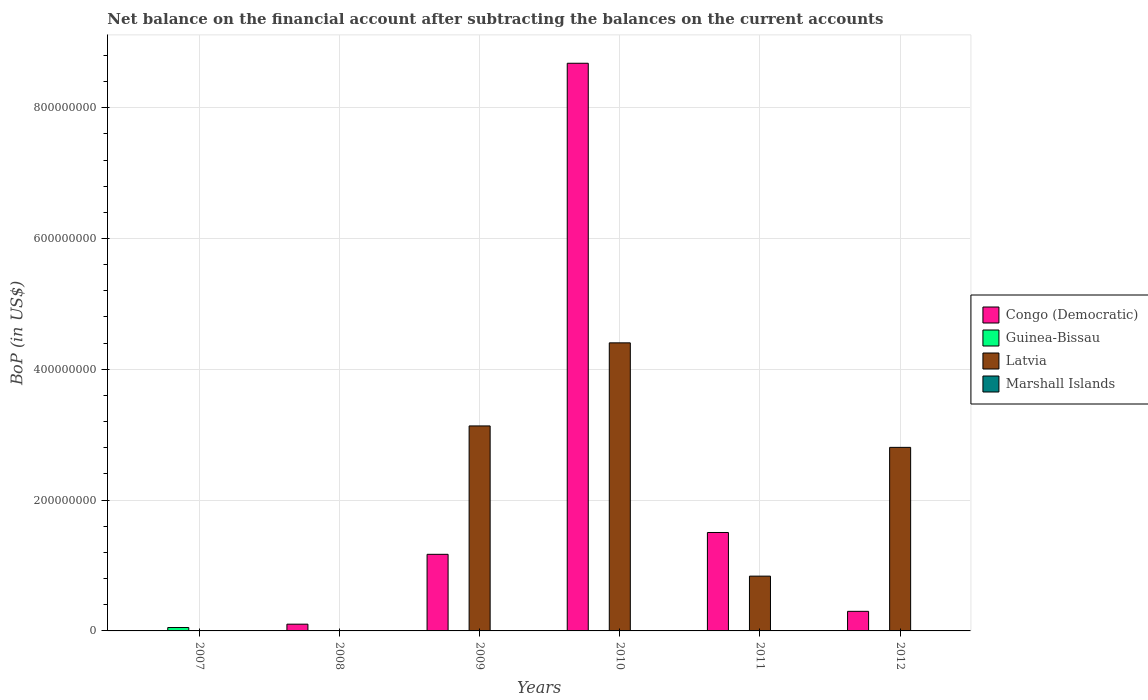Are the number of bars per tick equal to the number of legend labels?
Offer a very short reply. No. How many bars are there on the 2nd tick from the right?
Your response must be concise. 2. What is the label of the 2nd group of bars from the left?
Your answer should be compact. 2008. What is the Balance of Payments in Guinea-Bissau in 2008?
Give a very brief answer. 0. Across all years, what is the maximum Balance of Payments in Congo (Democratic)?
Ensure brevity in your answer.  8.68e+08. In which year was the Balance of Payments in Latvia maximum?
Your answer should be very brief. 2010. What is the total Balance of Payments in Guinea-Bissau in the graph?
Give a very brief answer. 5.20e+06. What is the difference between the Balance of Payments in Congo (Democratic) in 2010 and that in 2012?
Offer a terse response. 8.38e+08. What is the average Balance of Payments in Marshall Islands per year?
Provide a short and direct response. 0. What is the ratio of the Balance of Payments in Congo (Democratic) in 2010 to that in 2012?
Ensure brevity in your answer.  28.99. What is the difference between the highest and the second highest Balance of Payments in Latvia?
Offer a terse response. 1.27e+08. What is the difference between the highest and the lowest Balance of Payments in Congo (Democratic)?
Your answer should be very brief. 8.68e+08. In how many years, is the Balance of Payments in Congo (Democratic) greater than the average Balance of Payments in Congo (Democratic) taken over all years?
Your response must be concise. 1. Is it the case that in every year, the sum of the Balance of Payments in Latvia and Balance of Payments in Marshall Islands is greater than the sum of Balance of Payments in Congo (Democratic) and Balance of Payments in Guinea-Bissau?
Offer a very short reply. No. Is it the case that in every year, the sum of the Balance of Payments in Guinea-Bissau and Balance of Payments in Congo (Democratic) is greater than the Balance of Payments in Marshall Islands?
Your response must be concise. Yes. How many bars are there?
Ensure brevity in your answer.  10. Are all the bars in the graph horizontal?
Give a very brief answer. No. What is the difference between two consecutive major ticks on the Y-axis?
Keep it short and to the point. 2.00e+08. Are the values on the major ticks of Y-axis written in scientific E-notation?
Your answer should be very brief. No. Does the graph contain grids?
Offer a terse response. Yes. How many legend labels are there?
Give a very brief answer. 4. What is the title of the graph?
Provide a succinct answer. Net balance on the financial account after subtracting the balances on the current accounts. What is the label or title of the X-axis?
Give a very brief answer. Years. What is the label or title of the Y-axis?
Offer a terse response. BoP (in US$). What is the BoP (in US$) in Guinea-Bissau in 2007?
Offer a very short reply. 5.20e+06. What is the BoP (in US$) in Latvia in 2007?
Provide a short and direct response. 0. What is the BoP (in US$) in Congo (Democratic) in 2008?
Give a very brief answer. 1.03e+07. What is the BoP (in US$) of Guinea-Bissau in 2008?
Provide a succinct answer. 0. What is the BoP (in US$) of Marshall Islands in 2008?
Provide a succinct answer. 0. What is the BoP (in US$) of Congo (Democratic) in 2009?
Offer a very short reply. 1.17e+08. What is the BoP (in US$) of Guinea-Bissau in 2009?
Provide a succinct answer. 0. What is the BoP (in US$) in Latvia in 2009?
Provide a short and direct response. 3.13e+08. What is the BoP (in US$) of Congo (Democratic) in 2010?
Offer a very short reply. 8.68e+08. What is the BoP (in US$) in Guinea-Bissau in 2010?
Your answer should be compact. 0. What is the BoP (in US$) of Latvia in 2010?
Keep it short and to the point. 4.40e+08. What is the BoP (in US$) in Marshall Islands in 2010?
Keep it short and to the point. 0. What is the BoP (in US$) in Congo (Democratic) in 2011?
Offer a terse response. 1.50e+08. What is the BoP (in US$) in Guinea-Bissau in 2011?
Your answer should be very brief. 0. What is the BoP (in US$) of Latvia in 2011?
Your response must be concise. 8.38e+07. What is the BoP (in US$) in Marshall Islands in 2011?
Make the answer very short. 0. What is the BoP (in US$) in Congo (Democratic) in 2012?
Your response must be concise. 2.99e+07. What is the BoP (in US$) of Guinea-Bissau in 2012?
Your response must be concise. 0. What is the BoP (in US$) in Latvia in 2012?
Keep it short and to the point. 2.81e+08. What is the BoP (in US$) of Marshall Islands in 2012?
Ensure brevity in your answer.  0. Across all years, what is the maximum BoP (in US$) of Congo (Democratic)?
Give a very brief answer. 8.68e+08. Across all years, what is the maximum BoP (in US$) in Guinea-Bissau?
Provide a succinct answer. 5.20e+06. Across all years, what is the maximum BoP (in US$) in Latvia?
Ensure brevity in your answer.  4.40e+08. Across all years, what is the minimum BoP (in US$) of Latvia?
Keep it short and to the point. 0. What is the total BoP (in US$) in Congo (Democratic) in the graph?
Offer a very short reply. 1.18e+09. What is the total BoP (in US$) in Guinea-Bissau in the graph?
Offer a very short reply. 5.20e+06. What is the total BoP (in US$) of Latvia in the graph?
Your answer should be compact. 1.12e+09. What is the difference between the BoP (in US$) of Congo (Democratic) in 2008 and that in 2009?
Give a very brief answer. -1.07e+08. What is the difference between the BoP (in US$) of Congo (Democratic) in 2008 and that in 2010?
Offer a very short reply. -8.58e+08. What is the difference between the BoP (in US$) in Congo (Democratic) in 2008 and that in 2011?
Provide a succinct answer. -1.40e+08. What is the difference between the BoP (in US$) of Congo (Democratic) in 2008 and that in 2012?
Your answer should be very brief. -1.96e+07. What is the difference between the BoP (in US$) in Congo (Democratic) in 2009 and that in 2010?
Keep it short and to the point. -7.51e+08. What is the difference between the BoP (in US$) of Latvia in 2009 and that in 2010?
Ensure brevity in your answer.  -1.27e+08. What is the difference between the BoP (in US$) in Congo (Democratic) in 2009 and that in 2011?
Give a very brief answer. -3.34e+07. What is the difference between the BoP (in US$) of Latvia in 2009 and that in 2011?
Give a very brief answer. 2.30e+08. What is the difference between the BoP (in US$) of Congo (Democratic) in 2009 and that in 2012?
Give a very brief answer. 8.72e+07. What is the difference between the BoP (in US$) of Latvia in 2009 and that in 2012?
Give a very brief answer. 3.28e+07. What is the difference between the BoP (in US$) in Congo (Democratic) in 2010 and that in 2011?
Provide a succinct answer. 7.17e+08. What is the difference between the BoP (in US$) in Latvia in 2010 and that in 2011?
Give a very brief answer. 3.57e+08. What is the difference between the BoP (in US$) in Congo (Democratic) in 2010 and that in 2012?
Keep it short and to the point. 8.38e+08. What is the difference between the BoP (in US$) in Latvia in 2010 and that in 2012?
Provide a succinct answer. 1.60e+08. What is the difference between the BoP (in US$) of Congo (Democratic) in 2011 and that in 2012?
Offer a terse response. 1.21e+08. What is the difference between the BoP (in US$) of Latvia in 2011 and that in 2012?
Provide a short and direct response. -1.97e+08. What is the difference between the BoP (in US$) of Guinea-Bissau in 2007 and the BoP (in US$) of Latvia in 2009?
Offer a very short reply. -3.08e+08. What is the difference between the BoP (in US$) of Guinea-Bissau in 2007 and the BoP (in US$) of Latvia in 2010?
Keep it short and to the point. -4.35e+08. What is the difference between the BoP (in US$) in Guinea-Bissau in 2007 and the BoP (in US$) in Latvia in 2011?
Ensure brevity in your answer.  -7.86e+07. What is the difference between the BoP (in US$) in Guinea-Bissau in 2007 and the BoP (in US$) in Latvia in 2012?
Provide a succinct answer. -2.75e+08. What is the difference between the BoP (in US$) in Congo (Democratic) in 2008 and the BoP (in US$) in Latvia in 2009?
Your answer should be very brief. -3.03e+08. What is the difference between the BoP (in US$) of Congo (Democratic) in 2008 and the BoP (in US$) of Latvia in 2010?
Ensure brevity in your answer.  -4.30e+08. What is the difference between the BoP (in US$) in Congo (Democratic) in 2008 and the BoP (in US$) in Latvia in 2011?
Ensure brevity in your answer.  -7.35e+07. What is the difference between the BoP (in US$) in Congo (Democratic) in 2008 and the BoP (in US$) in Latvia in 2012?
Make the answer very short. -2.70e+08. What is the difference between the BoP (in US$) of Congo (Democratic) in 2009 and the BoP (in US$) of Latvia in 2010?
Your response must be concise. -3.23e+08. What is the difference between the BoP (in US$) in Congo (Democratic) in 2009 and the BoP (in US$) in Latvia in 2011?
Give a very brief answer. 3.34e+07. What is the difference between the BoP (in US$) of Congo (Democratic) in 2009 and the BoP (in US$) of Latvia in 2012?
Offer a terse response. -1.64e+08. What is the difference between the BoP (in US$) of Congo (Democratic) in 2010 and the BoP (in US$) of Latvia in 2011?
Your response must be concise. 7.84e+08. What is the difference between the BoP (in US$) in Congo (Democratic) in 2010 and the BoP (in US$) in Latvia in 2012?
Your answer should be compact. 5.87e+08. What is the difference between the BoP (in US$) in Congo (Democratic) in 2011 and the BoP (in US$) in Latvia in 2012?
Provide a short and direct response. -1.30e+08. What is the average BoP (in US$) of Congo (Democratic) per year?
Keep it short and to the point. 1.96e+08. What is the average BoP (in US$) in Guinea-Bissau per year?
Your answer should be very brief. 8.67e+05. What is the average BoP (in US$) of Latvia per year?
Offer a terse response. 1.86e+08. In the year 2009, what is the difference between the BoP (in US$) in Congo (Democratic) and BoP (in US$) in Latvia?
Make the answer very short. -1.96e+08. In the year 2010, what is the difference between the BoP (in US$) in Congo (Democratic) and BoP (in US$) in Latvia?
Offer a terse response. 4.27e+08. In the year 2011, what is the difference between the BoP (in US$) in Congo (Democratic) and BoP (in US$) in Latvia?
Provide a succinct answer. 6.67e+07. In the year 2012, what is the difference between the BoP (in US$) in Congo (Democratic) and BoP (in US$) in Latvia?
Ensure brevity in your answer.  -2.51e+08. What is the ratio of the BoP (in US$) of Congo (Democratic) in 2008 to that in 2009?
Your response must be concise. 0.09. What is the ratio of the BoP (in US$) of Congo (Democratic) in 2008 to that in 2010?
Make the answer very short. 0.01. What is the ratio of the BoP (in US$) in Congo (Democratic) in 2008 to that in 2011?
Make the answer very short. 0.07. What is the ratio of the BoP (in US$) of Congo (Democratic) in 2008 to that in 2012?
Keep it short and to the point. 0.34. What is the ratio of the BoP (in US$) of Congo (Democratic) in 2009 to that in 2010?
Ensure brevity in your answer.  0.14. What is the ratio of the BoP (in US$) in Latvia in 2009 to that in 2010?
Your answer should be compact. 0.71. What is the ratio of the BoP (in US$) in Congo (Democratic) in 2009 to that in 2011?
Offer a very short reply. 0.78. What is the ratio of the BoP (in US$) in Latvia in 2009 to that in 2011?
Keep it short and to the point. 3.74. What is the ratio of the BoP (in US$) of Congo (Democratic) in 2009 to that in 2012?
Your answer should be compact. 3.91. What is the ratio of the BoP (in US$) of Latvia in 2009 to that in 2012?
Offer a terse response. 1.12. What is the ratio of the BoP (in US$) of Congo (Democratic) in 2010 to that in 2011?
Provide a succinct answer. 5.77. What is the ratio of the BoP (in US$) in Latvia in 2010 to that in 2011?
Provide a succinct answer. 5.26. What is the ratio of the BoP (in US$) of Congo (Democratic) in 2010 to that in 2012?
Make the answer very short. 28.99. What is the ratio of the BoP (in US$) of Latvia in 2010 to that in 2012?
Provide a succinct answer. 1.57. What is the ratio of the BoP (in US$) of Congo (Democratic) in 2011 to that in 2012?
Provide a short and direct response. 5.03. What is the ratio of the BoP (in US$) of Latvia in 2011 to that in 2012?
Give a very brief answer. 0.3. What is the difference between the highest and the second highest BoP (in US$) of Congo (Democratic)?
Ensure brevity in your answer.  7.17e+08. What is the difference between the highest and the second highest BoP (in US$) in Latvia?
Give a very brief answer. 1.27e+08. What is the difference between the highest and the lowest BoP (in US$) in Congo (Democratic)?
Make the answer very short. 8.68e+08. What is the difference between the highest and the lowest BoP (in US$) in Guinea-Bissau?
Offer a terse response. 5.20e+06. What is the difference between the highest and the lowest BoP (in US$) of Latvia?
Your response must be concise. 4.40e+08. 